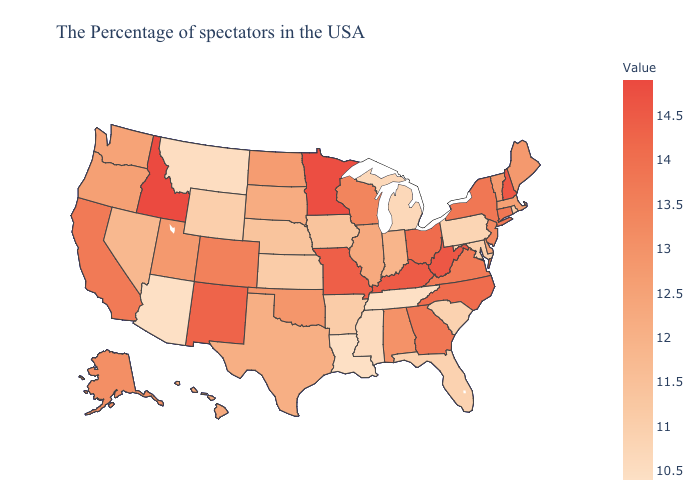Does Michigan have a higher value than Alaska?
Concise answer only. No. Does Idaho have the highest value in the USA?
Answer briefly. Yes. Does Utah have the lowest value in the West?
Write a very short answer. No. Among the states that border Kansas , which have the highest value?
Concise answer only. Missouri. Does the map have missing data?
Be succinct. No. Does Arkansas have the highest value in the South?
Be succinct. No. Which states have the highest value in the USA?
Short answer required. Idaho. 